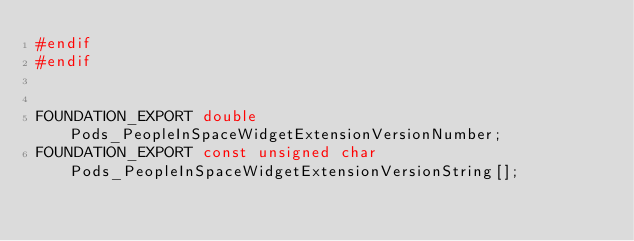Convert code to text. <code><loc_0><loc_0><loc_500><loc_500><_C_>#endif
#endif


FOUNDATION_EXPORT double Pods_PeopleInSpaceWidgetExtensionVersionNumber;
FOUNDATION_EXPORT const unsigned char Pods_PeopleInSpaceWidgetExtensionVersionString[];

</code> 